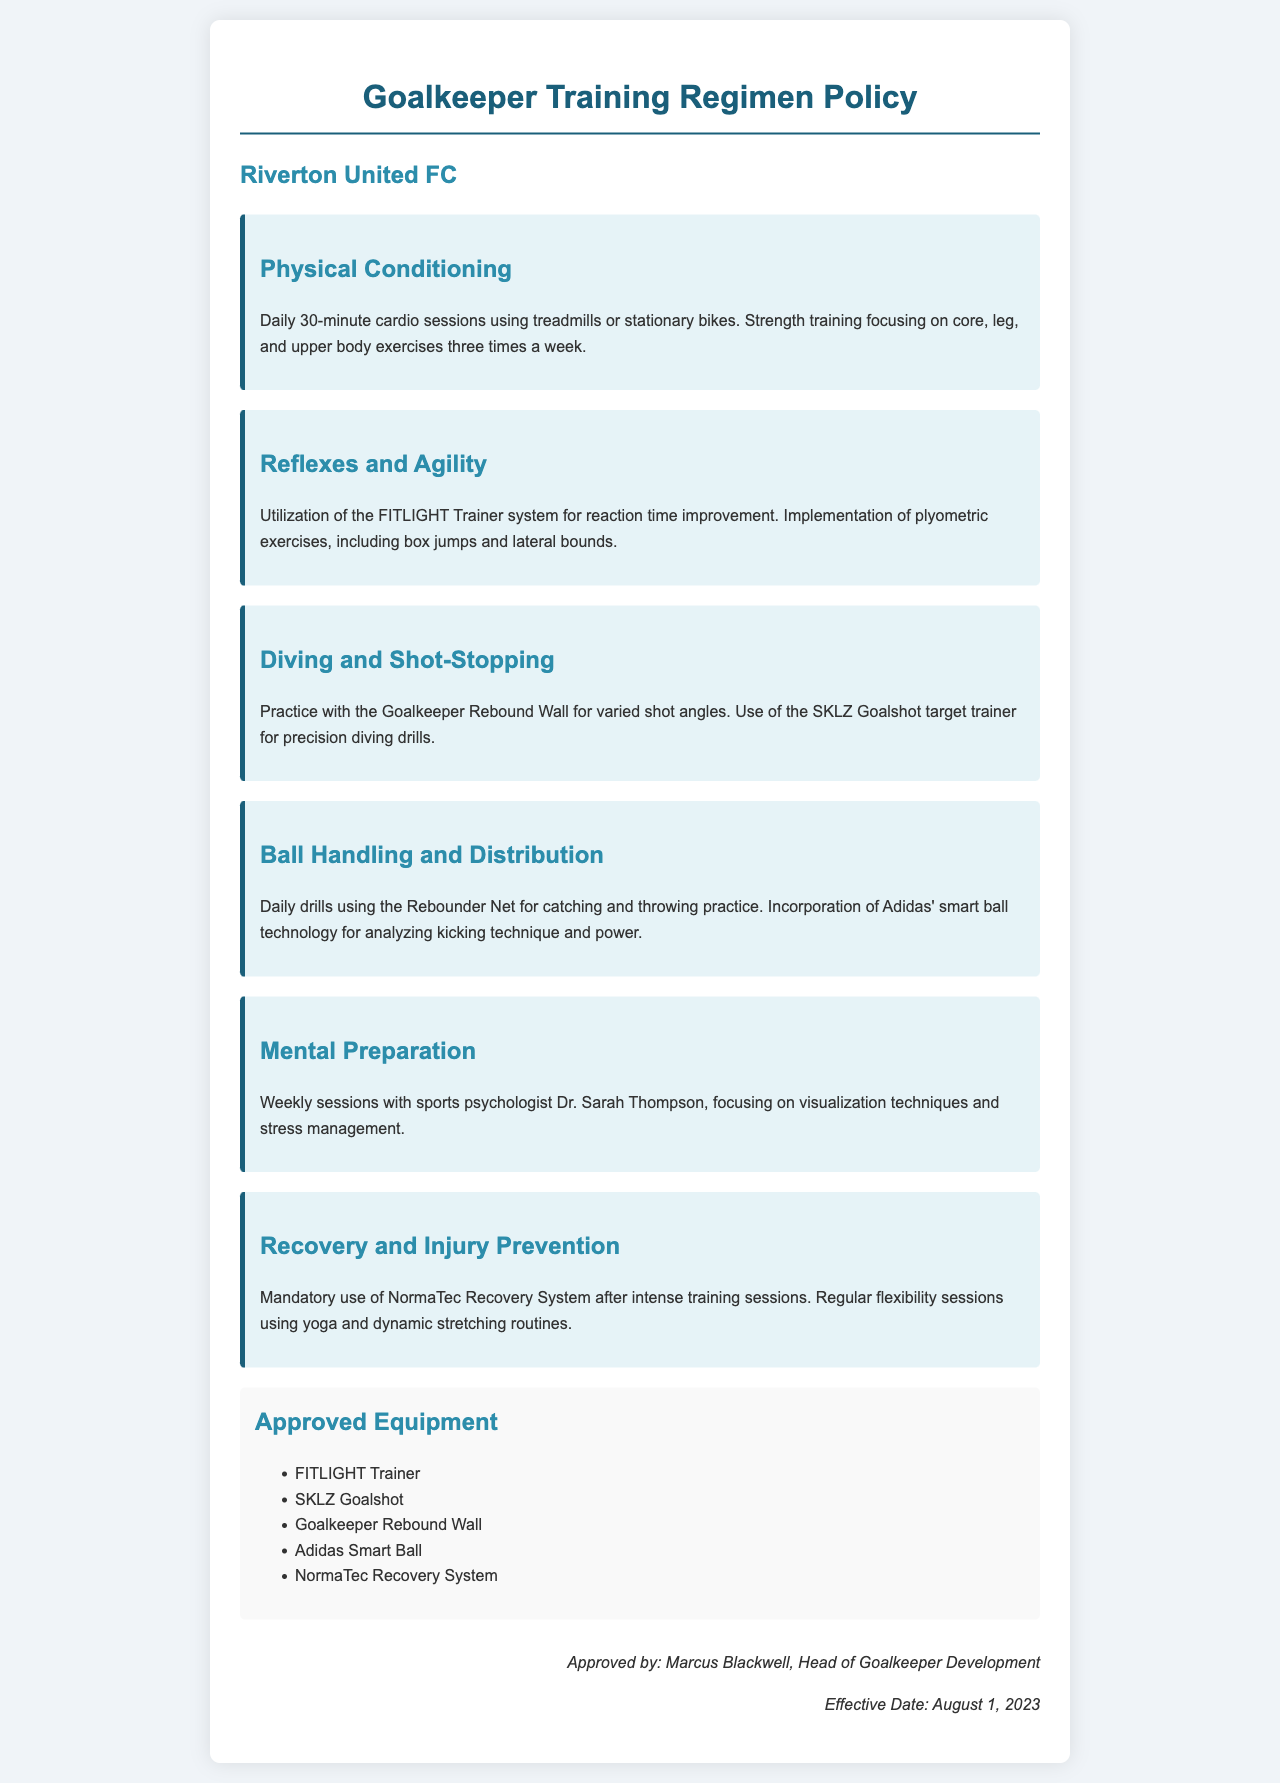What is the title of the document? The title of the document is stated at the top and indicates the focus of the content, which is about the training policies for goalkeepers.
Answer: Goalkeeper Training Regimen Policy Who is the head of goalkeeper development? The document lists the individual responsible for the approval of the policy, which is a key leadership role within the club.
Answer: Marcus Blackwell What is the effective date of the policy? The effective date is specified in the footer of the document, indicating when the policy came into force.
Answer: August 1, 2023 What is the duration of daily cardio sessions? The duration for the physical conditioning section outlines the time commitment required for cardio exercises, which is a key part of training.
Answer: 30 minutes What type of training is mandated after intense sessions? The recovery and injury prevention section specifies the equipment that must be used for recovery, emphasizing its importance in the training regimen.
Answer: NormaTec Recovery System Which psychologist is mentioned for mental preparation sessions? The document highlights the professional who conducts mental preparation, showing the importance of psychological readiness in training.
Answer: Dr. Sarah Thompson What specific equipment is used for precision diving drills? The section on diving and shot-stopping mentions specific equipment designed for practicing this critical skill, which is essential for goalkeepers.
Answer: SKLZ Goalshot What exercises are included in reflexes and agility training? The document lists specific exercises that aim to enhance important skills for goalkeepers, indicating the comprehensive nature of their training.
Answer: plyometric exercises What is the purpose of using Adidas' smart ball technology? The ball handling section indicates the technology's role in enhancing a specific aspect of goalkeeper training, illustrating a focus on skill improvement.
Answer: analyzing kicking technique and power 